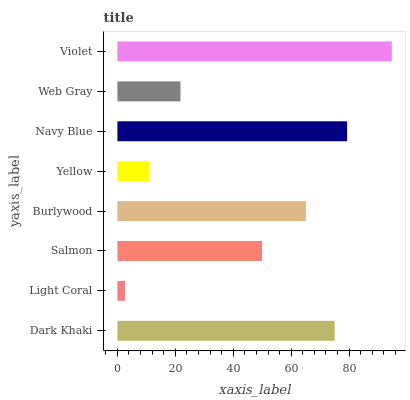Is Light Coral the minimum?
Answer yes or no. Yes. Is Violet the maximum?
Answer yes or no. Yes. Is Salmon the minimum?
Answer yes or no. No. Is Salmon the maximum?
Answer yes or no. No. Is Salmon greater than Light Coral?
Answer yes or no. Yes. Is Light Coral less than Salmon?
Answer yes or no. Yes. Is Light Coral greater than Salmon?
Answer yes or no. No. Is Salmon less than Light Coral?
Answer yes or no. No. Is Burlywood the high median?
Answer yes or no. Yes. Is Salmon the low median?
Answer yes or no. Yes. Is Violet the high median?
Answer yes or no. No. Is Dark Khaki the low median?
Answer yes or no. No. 